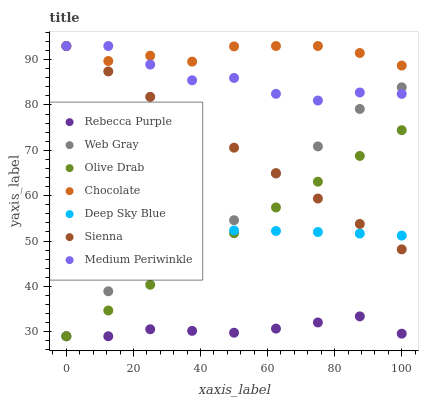Does Rebecca Purple have the minimum area under the curve?
Answer yes or no. Yes. Does Chocolate have the maximum area under the curve?
Answer yes or no. Yes. Does Medium Periwinkle have the minimum area under the curve?
Answer yes or no. No. Does Medium Periwinkle have the maximum area under the curve?
Answer yes or no. No. Is Sienna the smoothest?
Answer yes or no. Yes. Is Web Gray the roughest?
Answer yes or no. Yes. Is Medium Periwinkle the smoothest?
Answer yes or no. No. Is Medium Periwinkle the roughest?
Answer yes or no. No. Does Web Gray have the lowest value?
Answer yes or no. Yes. Does Medium Periwinkle have the lowest value?
Answer yes or no. No. Does Sienna have the highest value?
Answer yes or no. Yes. Does Rebecca Purple have the highest value?
Answer yes or no. No. Is Olive Drab less than Chocolate?
Answer yes or no. Yes. Is Chocolate greater than Olive Drab?
Answer yes or no. Yes. Does Medium Periwinkle intersect Web Gray?
Answer yes or no. Yes. Is Medium Periwinkle less than Web Gray?
Answer yes or no. No. Is Medium Periwinkle greater than Web Gray?
Answer yes or no. No. Does Olive Drab intersect Chocolate?
Answer yes or no. No. 